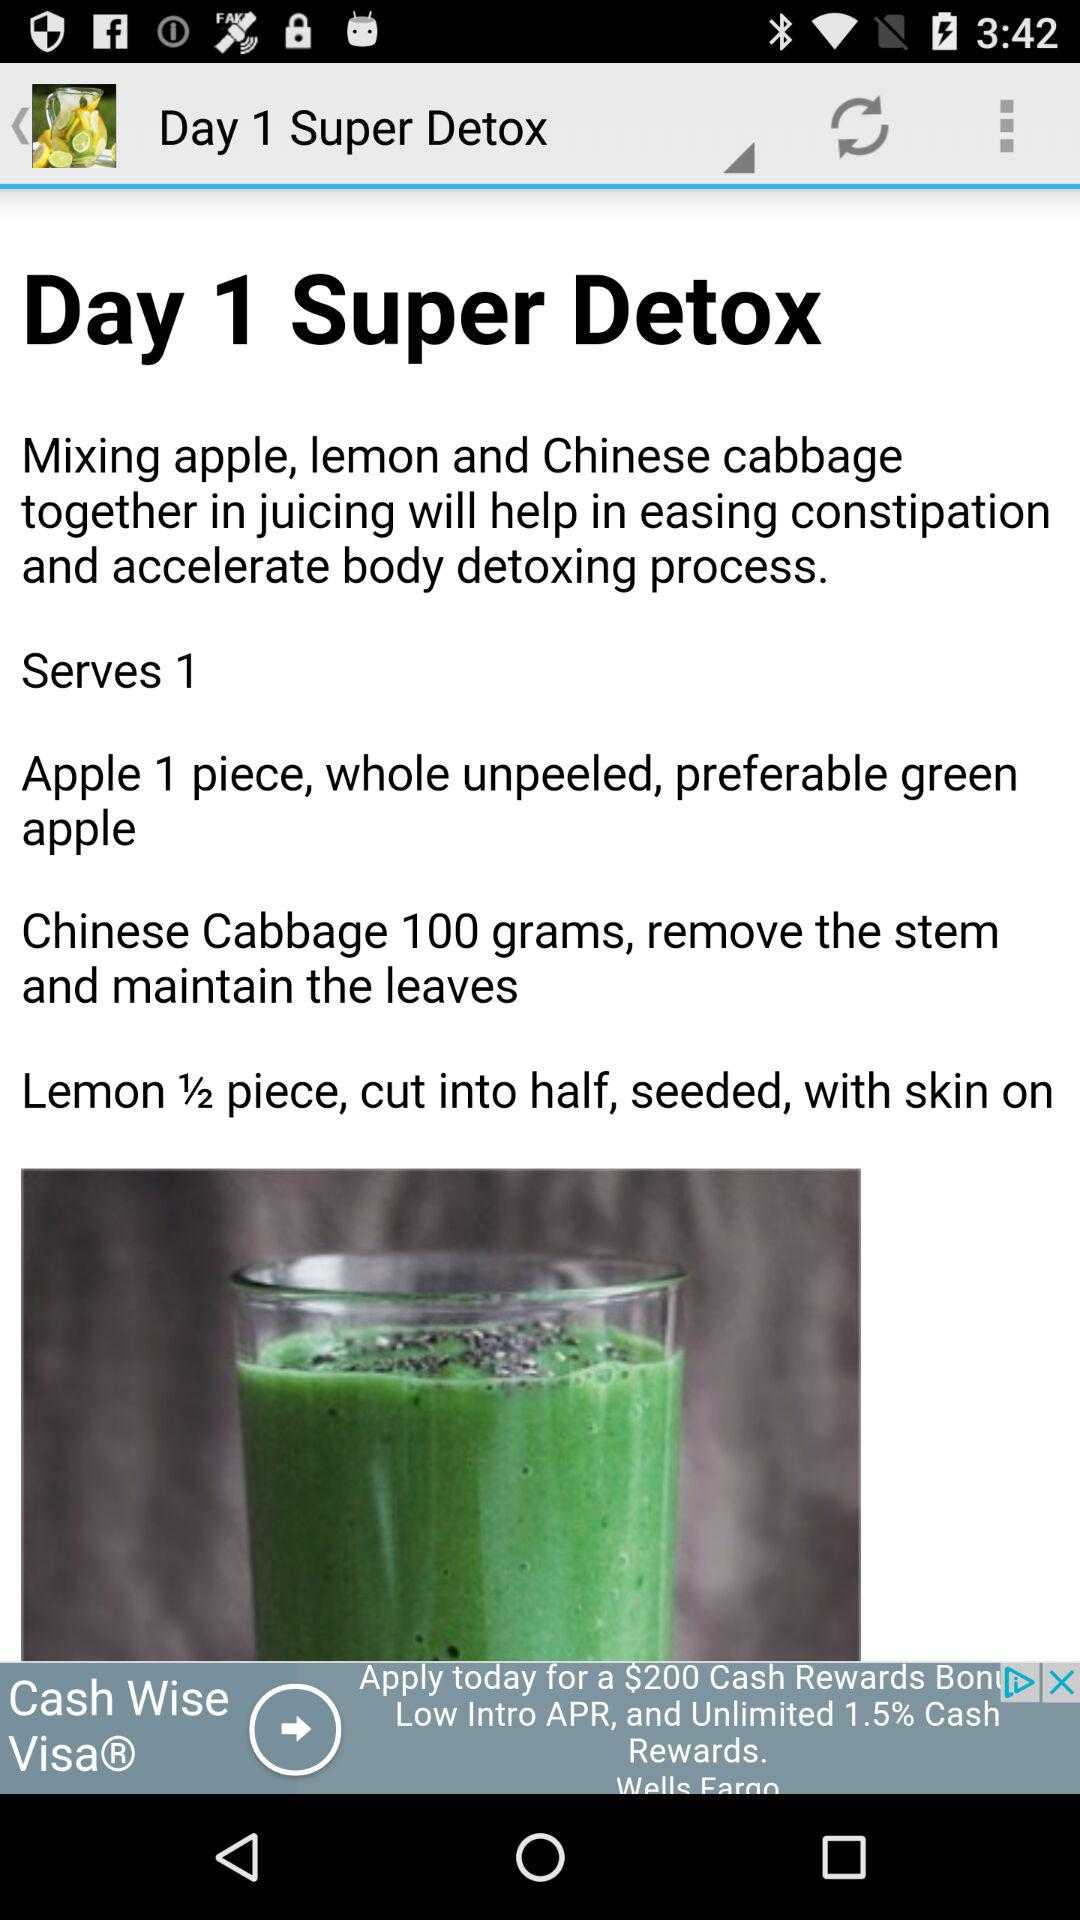What are the benefits of "Super Detox"? The benefits of "Super Detox" are that it helps ease constipation and accelerates the body's detoxification process. 